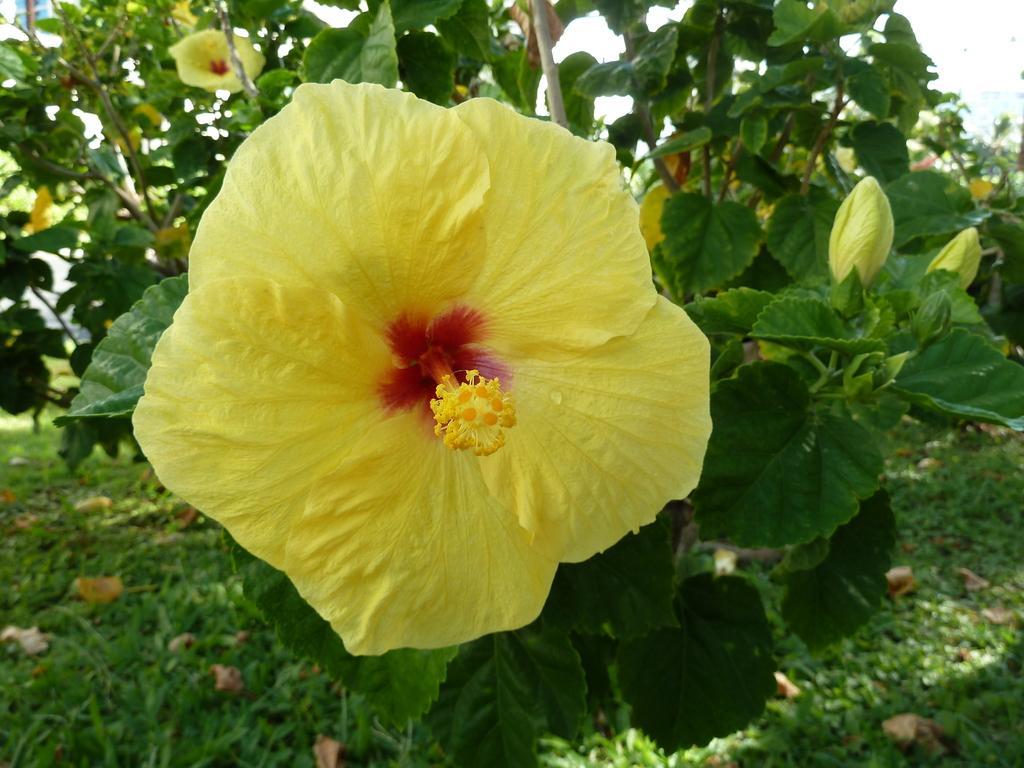How would you summarize this image in a sentence or two? In this image there are yellow color flowers and green leaves. There is grass. 